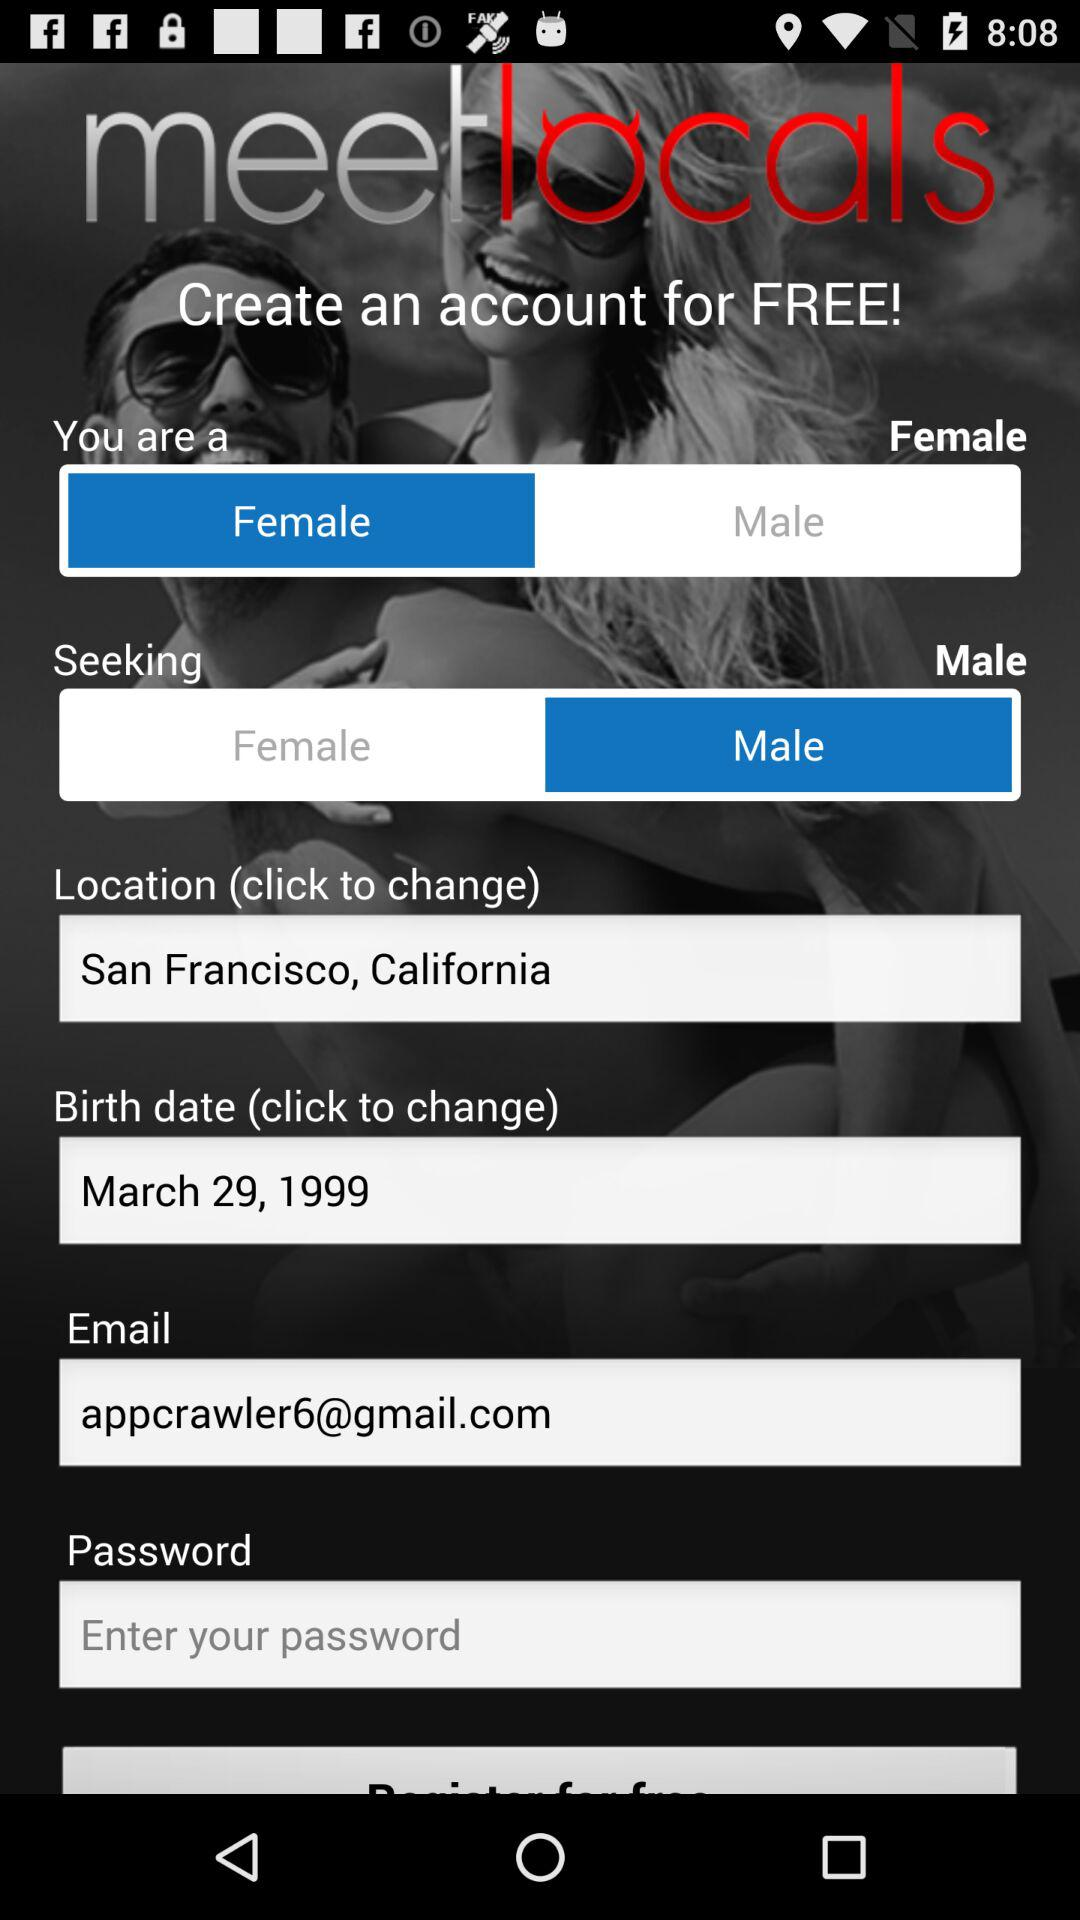What is the option for gender? The options for gender are "Female" and "Male". 